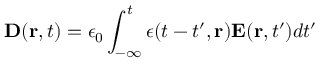<formula> <loc_0><loc_0><loc_500><loc_500>{ D } ( { r } , t ) = \epsilon _ { 0 } \int _ { - \infty } ^ { t } \epsilon ( t - t ^ { \prime } , { r } ) { E } ( { r } , t ^ { \prime } ) d t ^ { \prime }</formula> 